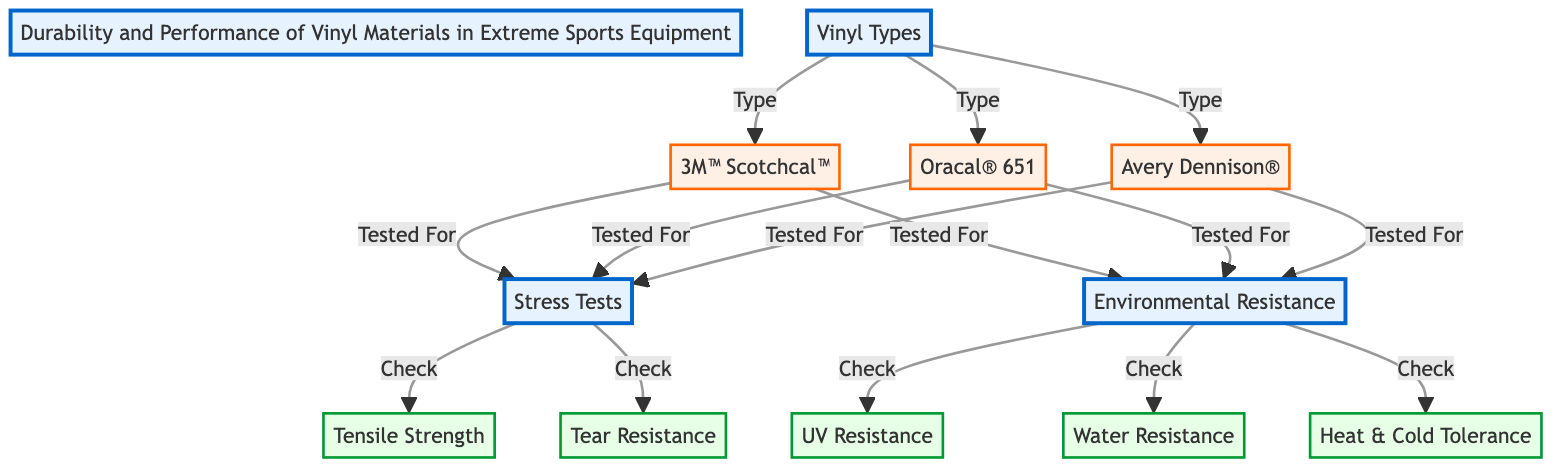What are the three types of vinyl materials listed in the diagram? The diagram lists three vinyl materials under the "Vinyl Types" node: 3M™ Scotchcal™, Oracal® 651, and Avery Dennison®.
Answer: 3M™ Scotchcal™, Oracal® 651, Avery Dennison® Which testing category checks for UV resistance? The test category "Environmental Resistance" contains the UV resistance check, as shown in the diagram.
Answer: Environmental Resistance How many types of stress tests are listed in the diagram? The diagram indicates two types of stress tests under the "Stress Tests" category: tensile strength and tear resistance.
Answer: 2 What materials are tested for environmental resistance? All three vinyl materials—the 3M™ Scotchcal™, Oracal® 651, and Avery Dennison®—are linked to the "Environmental Resistance" tests, indicating they are all tested.
Answer: 3 Which vinyl material is tested for both tensile strength and tear resistance? The diagram shows that all vinyl materials (3M™ Scotchcal™, Oracal® 651, and Avery Dennison®) are tested for tensile strength and tear resistance under the "Stress Tests" node.
Answer: All What environmental factors are vinyl materials resistant to according to the diagram? The environmental resistance checks include UV resistance, water resistance, and heat & cold tolerance, as outlined in the diagram.
Answer: UV resistance, water resistance, heat & cold tolerance Do all vinyl types undergo all the tests mentioned? The diagram shows that each vinyl type undergoes certain tests; for example, they all undergo environmental resistance tests but not all undergo all stress tests equally, indicating some do not.
Answer: No What is the relationship between vinyl types and stress tests? The vinyl types are directly linked to the stress tests with the label "Tested For," showing that stress tests are applicable to each vinyl type listed.
Answer: Tested For 